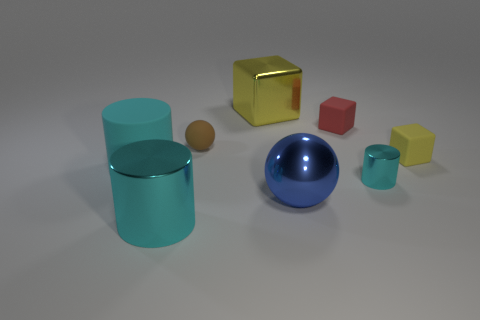Subtract all cyan cylinders. How many were subtracted if there are1cyan cylinders left? 2 Add 2 big blue shiny balls. How many objects exist? 10 Subtract all blocks. How many objects are left? 5 Subtract all brown balls. Subtract all big metal spheres. How many objects are left? 6 Add 2 tiny metallic cylinders. How many tiny metallic cylinders are left? 3 Add 6 small balls. How many small balls exist? 7 Subtract 0 red balls. How many objects are left? 8 